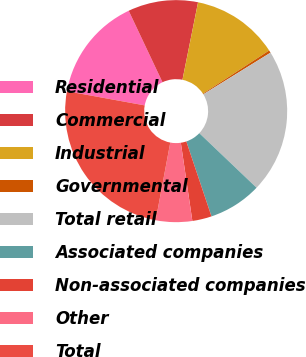<chart> <loc_0><loc_0><loc_500><loc_500><pie_chart><fcel>Residential<fcel>Commercial<fcel>Industrial<fcel>Governmental<fcel>Total retail<fcel>Associated companies<fcel>Non-associated companies<fcel>Other<fcel>Total<nl><fcel>15.1%<fcel>10.19%<fcel>12.64%<fcel>0.37%<fcel>20.94%<fcel>7.73%<fcel>2.82%<fcel>5.28%<fcel>24.92%<nl></chart> 